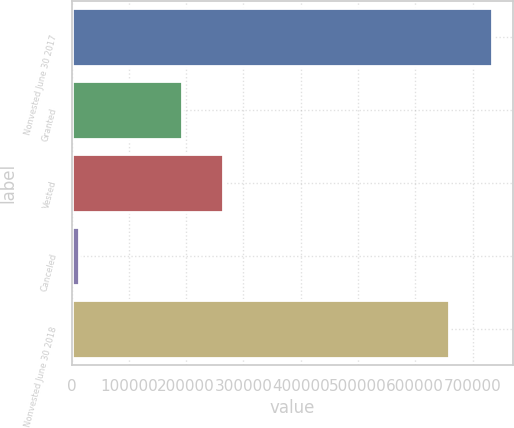Convert chart. <chart><loc_0><loc_0><loc_500><loc_500><bar_chart><fcel>Nonvested June 30 2017<fcel>Granted<fcel>Vested<fcel>Canceled<fcel>Nonvested June 30 2018<nl><fcel>734744<fcel>191986<fcel>264222<fcel>12388<fcel>658271<nl></chart> 